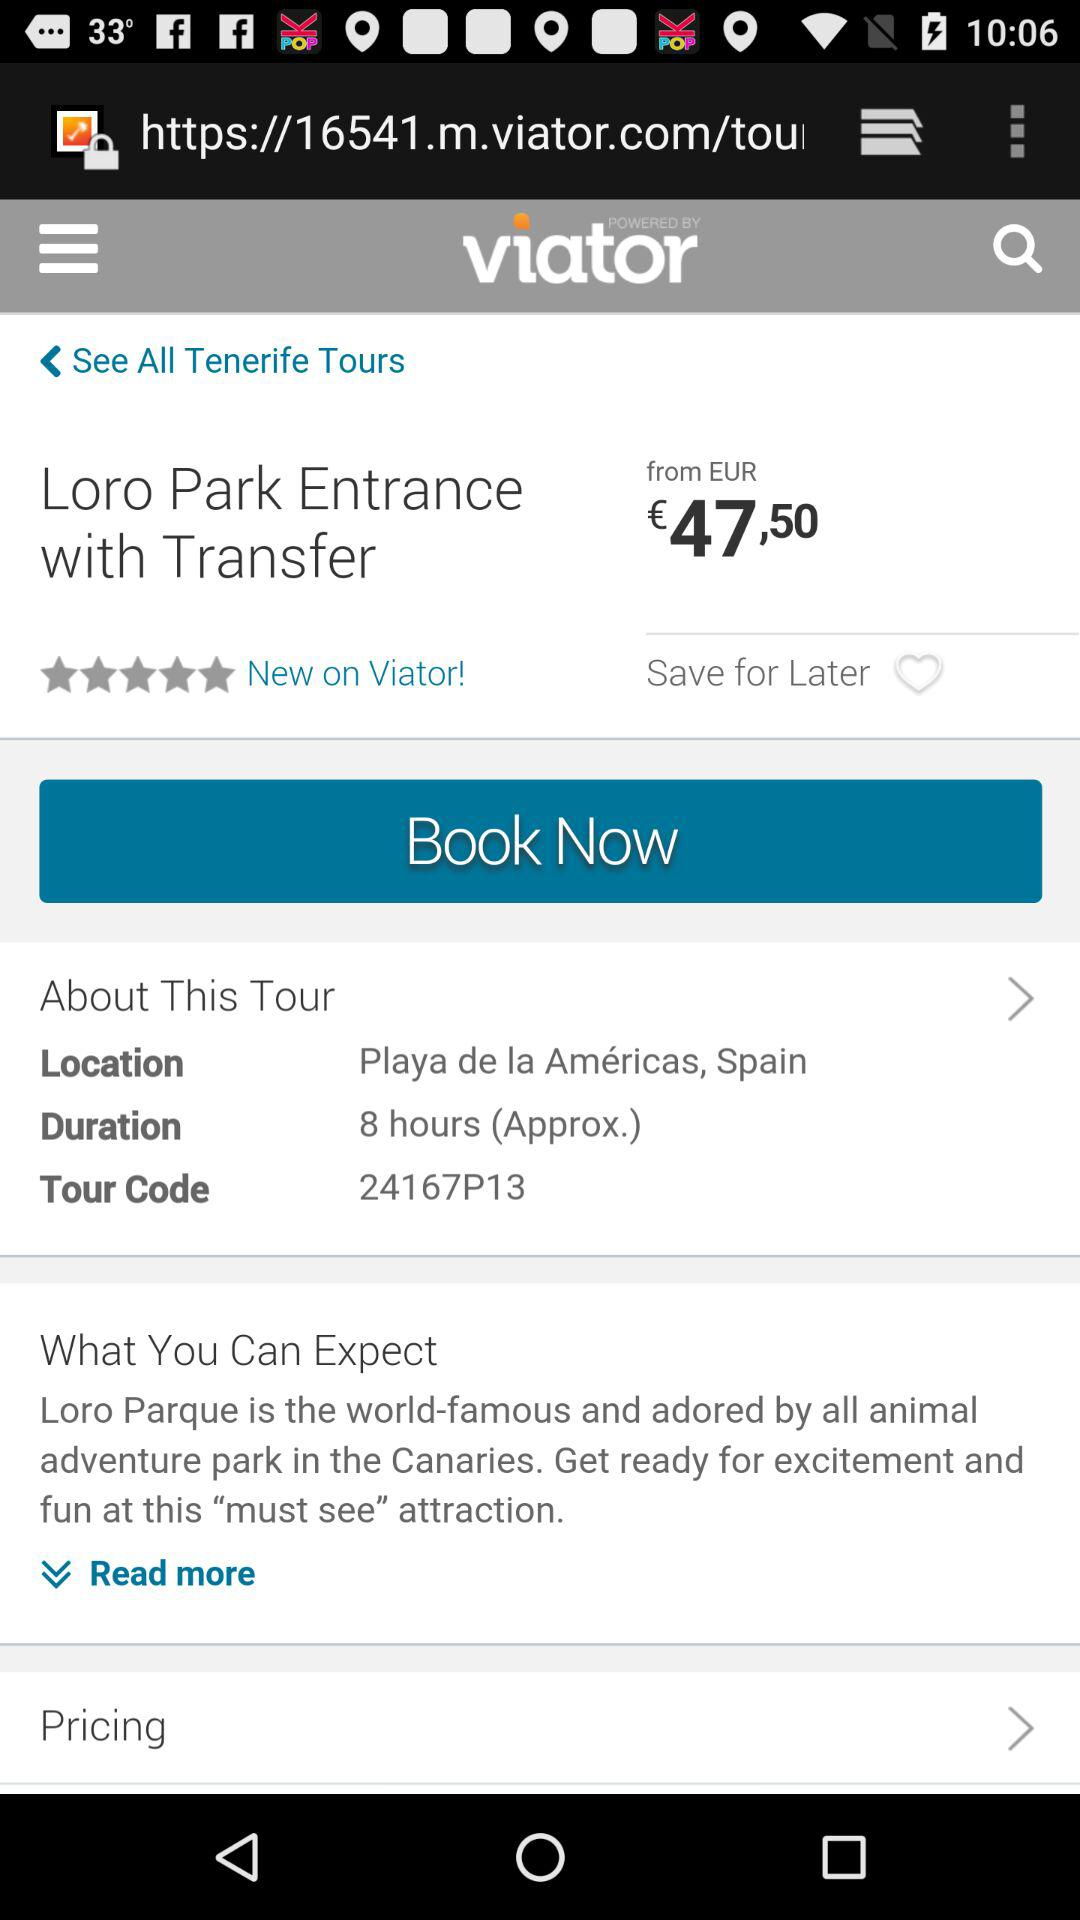What is the tour code? The tour code is "24167P13". 